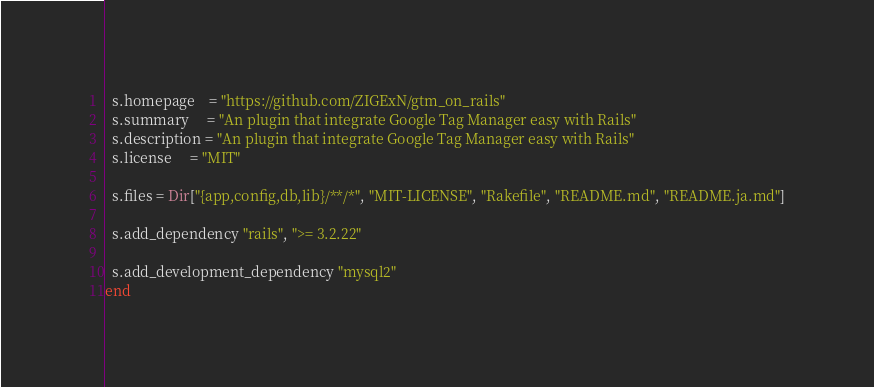Convert code to text. <code><loc_0><loc_0><loc_500><loc_500><_Ruby_>  s.homepage    = "https://github.com/ZIGExN/gtm_on_rails"
  s.summary     = "An plugin that integrate Google Tag Manager easy with Rails"
  s.description = "An plugin that integrate Google Tag Manager easy with Rails"
  s.license     = "MIT"

  s.files = Dir["{app,config,db,lib}/**/*", "MIT-LICENSE", "Rakefile", "README.md", "README.ja.md"]

  s.add_dependency "rails", ">= 3.2.22"

  s.add_development_dependency "mysql2"
end
</code> 